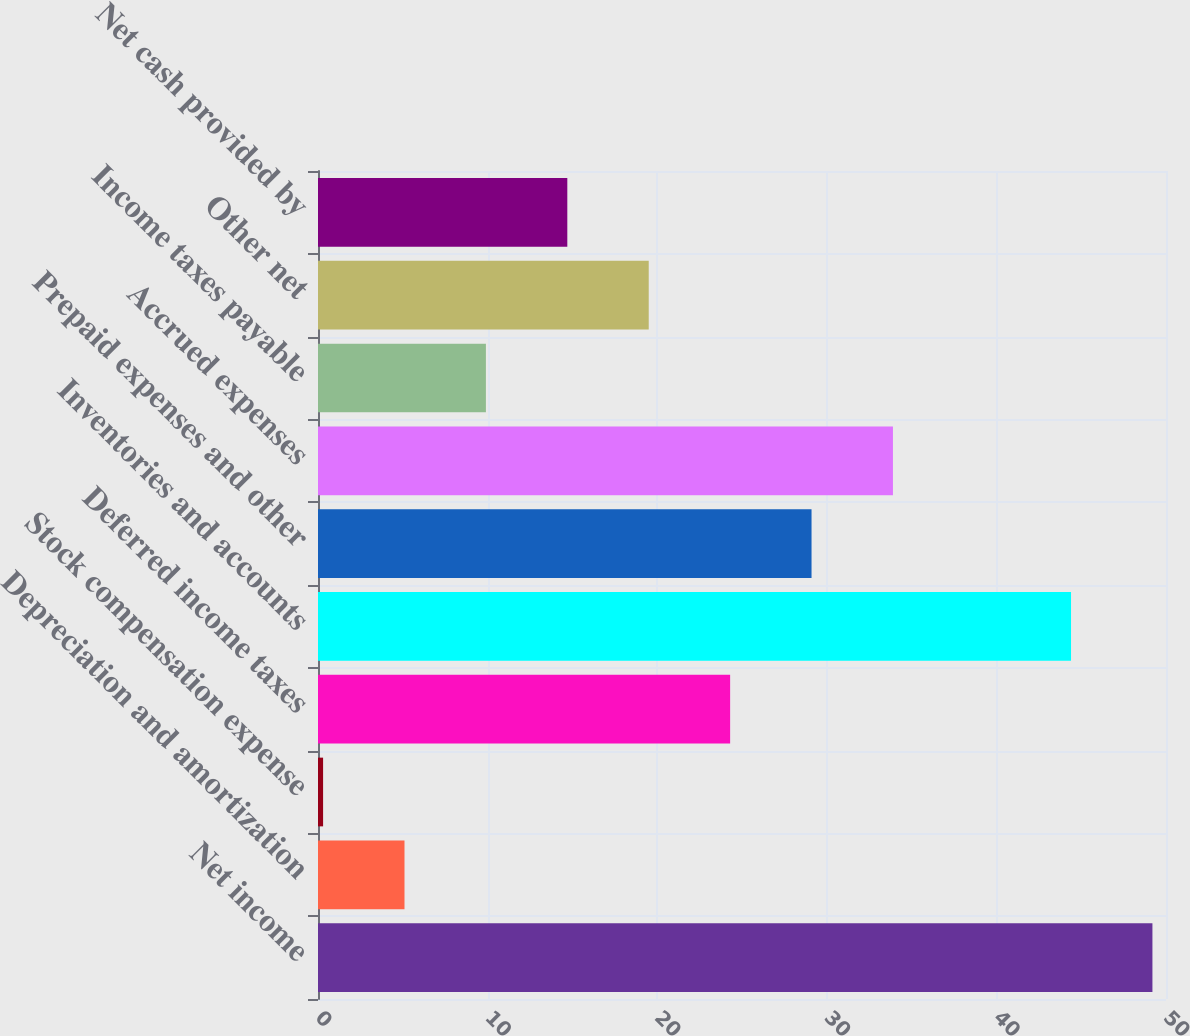<chart> <loc_0><loc_0><loc_500><loc_500><bar_chart><fcel>Net income<fcel>Depreciation and amortization<fcel>Stock compensation expense<fcel>Deferred income taxes<fcel>Inventories and accounts<fcel>Prepaid expenses and other<fcel>Accrued expenses<fcel>Income taxes payable<fcel>Other net<fcel>Net cash provided by<nl><fcel>49.2<fcel>5.1<fcel>0.3<fcel>24.3<fcel>44.4<fcel>29.1<fcel>33.9<fcel>9.9<fcel>19.5<fcel>14.7<nl></chart> 